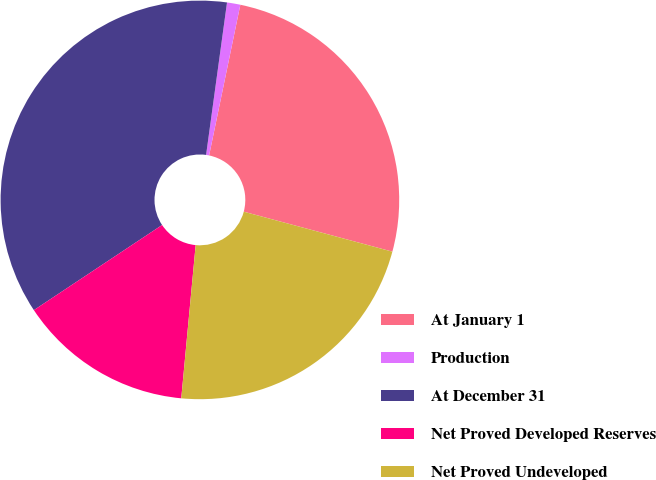Convert chart to OTSL. <chart><loc_0><loc_0><loc_500><loc_500><pie_chart><fcel>At January 1<fcel>Production<fcel>At December 31<fcel>Net Proved Developed Reserves<fcel>Net Proved Undeveloped<nl><fcel>25.93%<fcel>1.08%<fcel>36.5%<fcel>14.18%<fcel>22.31%<nl></chart> 